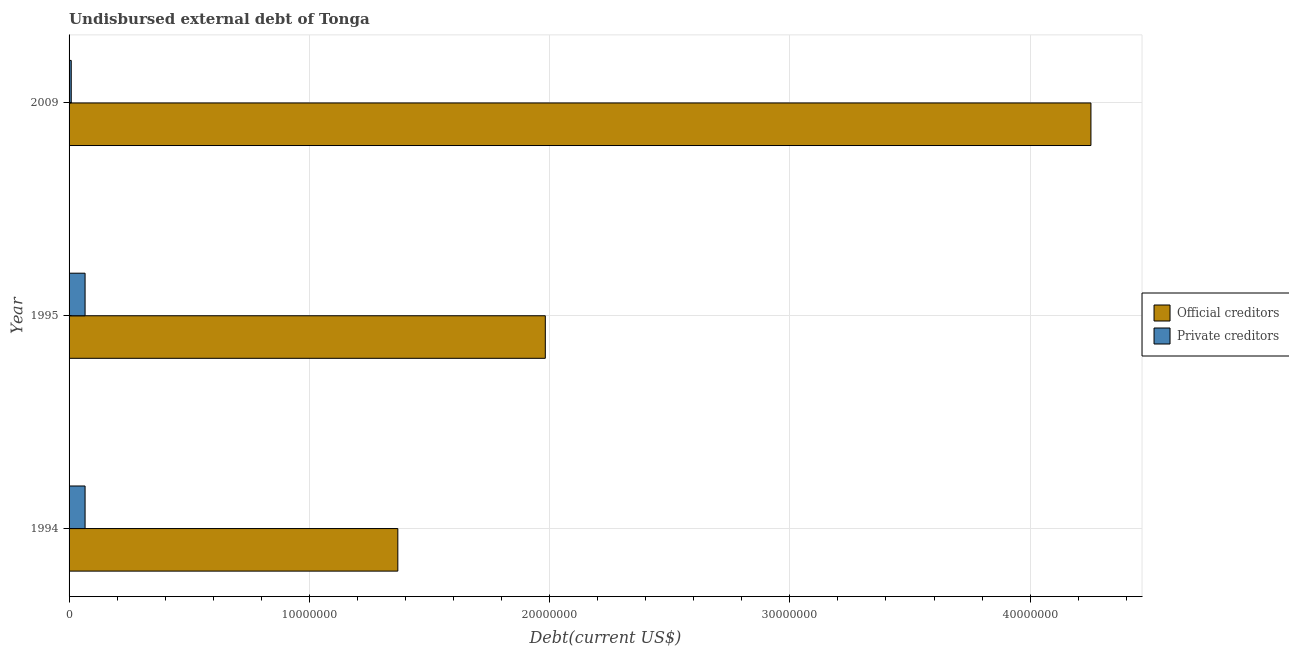How many groups of bars are there?
Your answer should be very brief. 3. Are the number of bars on each tick of the Y-axis equal?
Ensure brevity in your answer.  Yes. What is the label of the 1st group of bars from the top?
Your answer should be compact. 2009. What is the undisbursed external debt of official creditors in 1995?
Keep it short and to the point. 1.98e+07. Across all years, what is the maximum undisbursed external debt of official creditors?
Provide a short and direct response. 4.25e+07. Across all years, what is the minimum undisbursed external debt of official creditors?
Offer a terse response. 1.37e+07. In which year was the undisbursed external debt of official creditors minimum?
Your response must be concise. 1994. What is the total undisbursed external debt of private creditors in the graph?
Provide a short and direct response. 1.42e+06. What is the difference between the undisbursed external debt of official creditors in 1995 and that in 2009?
Ensure brevity in your answer.  -2.27e+07. What is the difference between the undisbursed external debt of private creditors in 1995 and the undisbursed external debt of official creditors in 1994?
Keep it short and to the point. -1.30e+07. What is the average undisbursed external debt of private creditors per year?
Ensure brevity in your answer.  4.74e+05. In the year 2009, what is the difference between the undisbursed external debt of private creditors and undisbursed external debt of official creditors?
Offer a very short reply. -4.24e+07. What is the ratio of the undisbursed external debt of official creditors in 1994 to that in 1995?
Your response must be concise. 0.69. What is the difference between the highest and the second highest undisbursed external debt of official creditors?
Your answer should be compact. 2.27e+07. What is the difference between the highest and the lowest undisbursed external debt of official creditors?
Make the answer very short. 2.88e+07. In how many years, is the undisbursed external debt of official creditors greater than the average undisbursed external debt of official creditors taken over all years?
Offer a terse response. 1. What does the 1st bar from the top in 1995 represents?
Make the answer very short. Private creditors. What does the 1st bar from the bottom in 1994 represents?
Offer a very short reply. Official creditors. How many bars are there?
Your answer should be compact. 6. Are all the bars in the graph horizontal?
Provide a succinct answer. Yes. How many years are there in the graph?
Provide a short and direct response. 3. Does the graph contain grids?
Provide a short and direct response. Yes. How many legend labels are there?
Offer a terse response. 2. How are the legend labels stacked?
Make the answer very short. Vertical. What is the title of the graph?
Your response must be concise. Undisbursed external debt of Tonga. What is the label or title of the X-axis?
Your answer should be compact. Debt(current US$). What is the Debt(current US$) of Official creditors in 1994?
Give a very brief answer. 1.37e+07. What is the Debt(current US$) in Private creditors in 1994?
Offer a terse response. 6.66e+05. What is the Debt(current US$) in Official creditors in 1995?
Your answer should be very brief. 1.98e+07. What is the Debt(current US$) of Private creditors in 1995?
Offer a very short reply. 6.66e+05. What is the Debt(current US$) of Official creditors in 2009?
Provide a short and direct response. 4.25e+07. Across all years, what is the maximum Debt(current US$) of Official creditors?
Offer a terse response. 4.25e+07. Across all years, what is the maximum Debt(current US$) of Private creditors?
Keep it short and to the point. 6.66e+05. Across all years, what is the minimum Debt(current US$) of Official creditors?
Ensure brevity in your answer.  1.37e+07. Across all years, what is the minimum Debt(current US$) of Private creditors?
Provide a short and direct response. 9.00e+04. What is the total Debt(current US$) in Official creditors in the graph?
Ensure brevity in your answer.  7.60e+07. What is the total Debt(current US$) of Private creditors in the graph?
Give a very brief answer. 1.42e+06. What is the difference between the Debt(current US$) in Official creditors in 1994 and that in 1995?
Make the answer very short. -6.14e+06. What is the difference between the Debt(current US$) of Official creditors in 1994 and that in 2009?
Provide a succinct answer. -2.88e+07. What is the difference between the Debt(current US$) in Private creditors in 1994 and that in 2009?
Keep it short and to the point. 5.76e+05. What is the difference between the Debt(current US$) in Official creditors in 1995 and that in 2009?
Keep it short and to the point. -2.27e+07. What is the difference between the Debt(current US$) in Private creditors in 1995 and that in 2009?
Offer a very short reply. 5.76e+05. What is the difference between the Debt(current US$) of Official creditors in 1994 and the Debt(current US$) of Private creditors in 1995?
Make the answer very short. 1.30e+07. What is the difference between the Debt(current US$) in Official creditors in 1994 and the Debt(current US$) in Private creditors in 2009?
Provide a succinct answer. 1.36e+07. What is the difference between the Debt(current US$) in Official creditors in 1995 and the Debt(current US$) in Private creditors in 2009?
Your answer should be compact. 1.97e+07. What is the average Debt(current US$) of Official creditors per year?
Your answer should be very brief. 2.53e+07. What is the average Debt(current US$) in Private creditors per year?
Offer a very short reply. 4.74e+05. In the year 1994, what is the difference between the Debt(current US$) in Official creditors and Debt(current US$) in Private creditors?
Give a very brief answer. 1.30e+07. In the year 1995, what is the difference between the Debt(current US$) in Official creditors and Debt(current US$) in Private creditors?
Keep it short and to the point. 1.92e+07. In the year 2009, what is the difference between the Debt(current US$) in Official creditors and Debt(current US$) in Private creditors?
Make the answer very short. 4.24e+07. What is the ratio of the Debt(current US$) of Official creditors in 1994 to that in 1995?
Provide a short and direct response. 0.69. What is the ratio of the Debt(current US$) of Official creditors in 1994 to that in 2009?
Your response must be concise. 0.32. What is the ratio of the Debt(current US$) in Private creditors in 1994 to that in 2009?
Provide a succinct answer. 7.4. What is the ratio of the Debt(current US$) of Official creditors in 1995 to that in 2009?
Offer a very short reply. 0.47. What is the ratio of the Debt(current US$) in Private creditors in 1995 to that in 2009?
Your answer should be very brief. 7.4. What is the difference between the highest and the second highest Debt(current US$) in Official creditors?
Keep it short and to the point. 2.27e+07. What is the difference between the highest and the lowest Debt(current US$) in Official creditors?
Your response must be concise. 2.88e+07. What is the difference between the highest and the lowest Debt(current US$) in Private creditors?
Keep it short and to the point. 5.76e+05. 